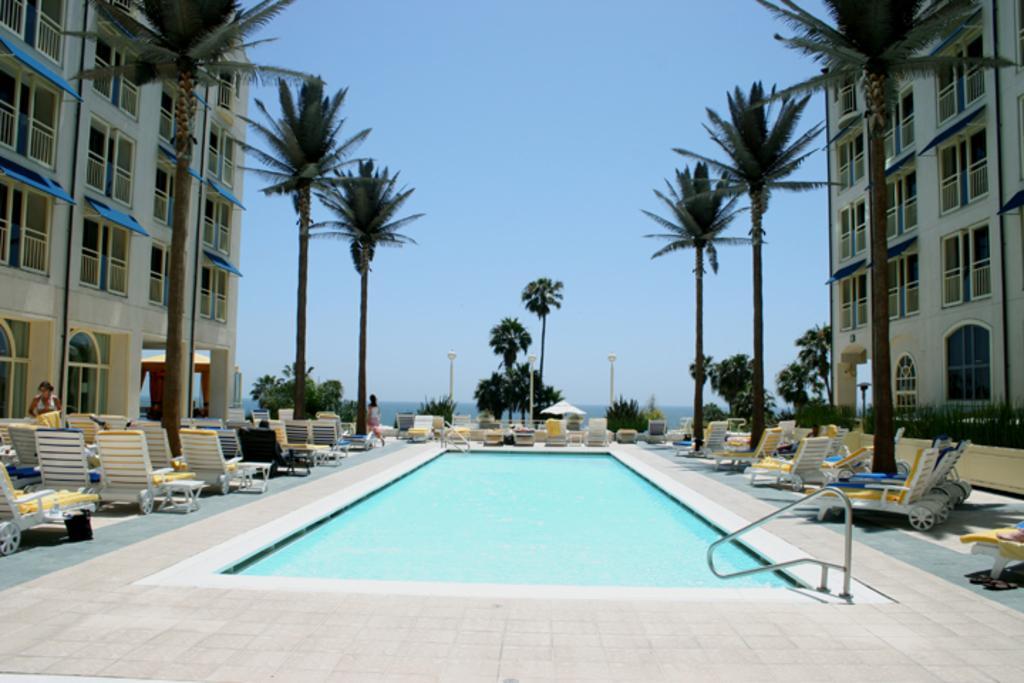How would you summarize this image in a sentence or two? In this image, we can see a swimming pool in between trees and buildings. There are chairs on the left and on the right side of the image. There is a sky at the top of the image. 